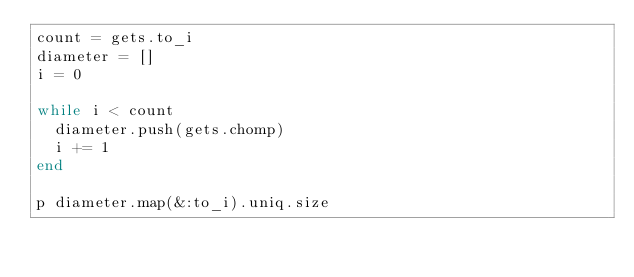<code> <loc_0><loc_0><loc_500><loc_500><_Ruby_>count = gets.to_i
diameter = []
i = 0

while i < count
  diameter.push(gets.chomp)
  i += 1
end

p diameter.map(&:to_i).uniq.size
</code> 